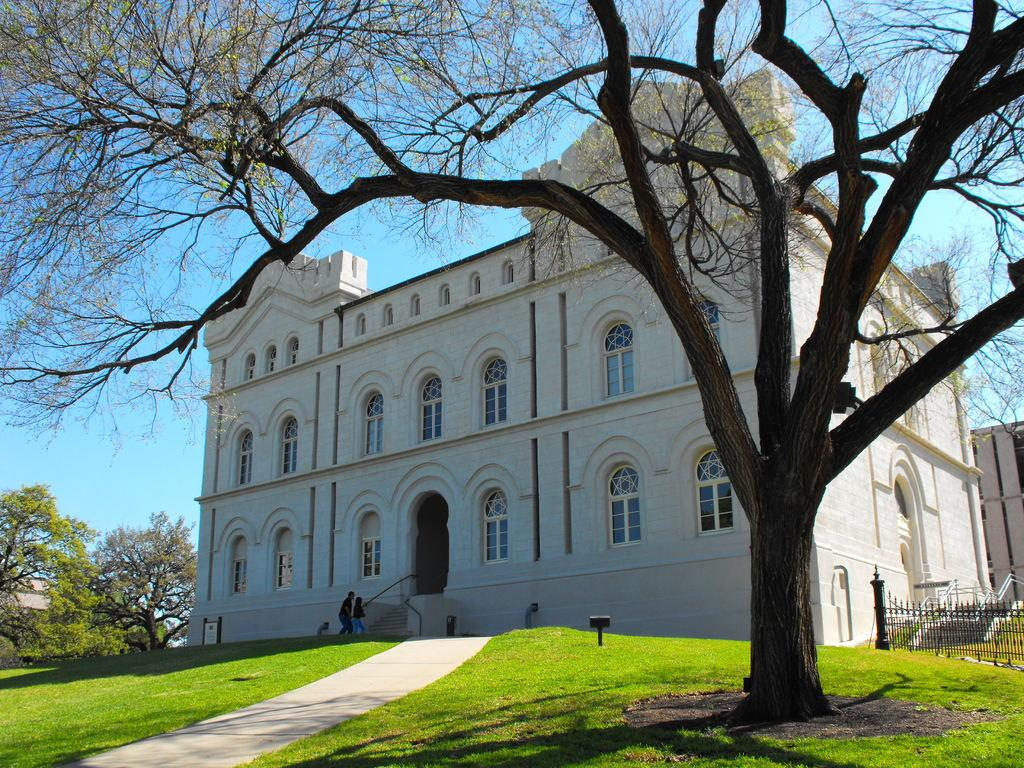What type of vegetation is present in the image? There is grass in the image. What type of structure can be seen in the image? There is a fence in the image. What other natural elements are visible in the image? There are trees in the image. What type of man-made structure is present in the image? There is a building in the image. How many people are in the image? There are two persons in the image. What is visible in the background of the image? The sky is visible in the background of the image. How many lizards are sitting on the building in the image? There are no lizards present in the image. What type of meat is being grilled on the grass in the image? There is no meat or grilling activity present in the image. 